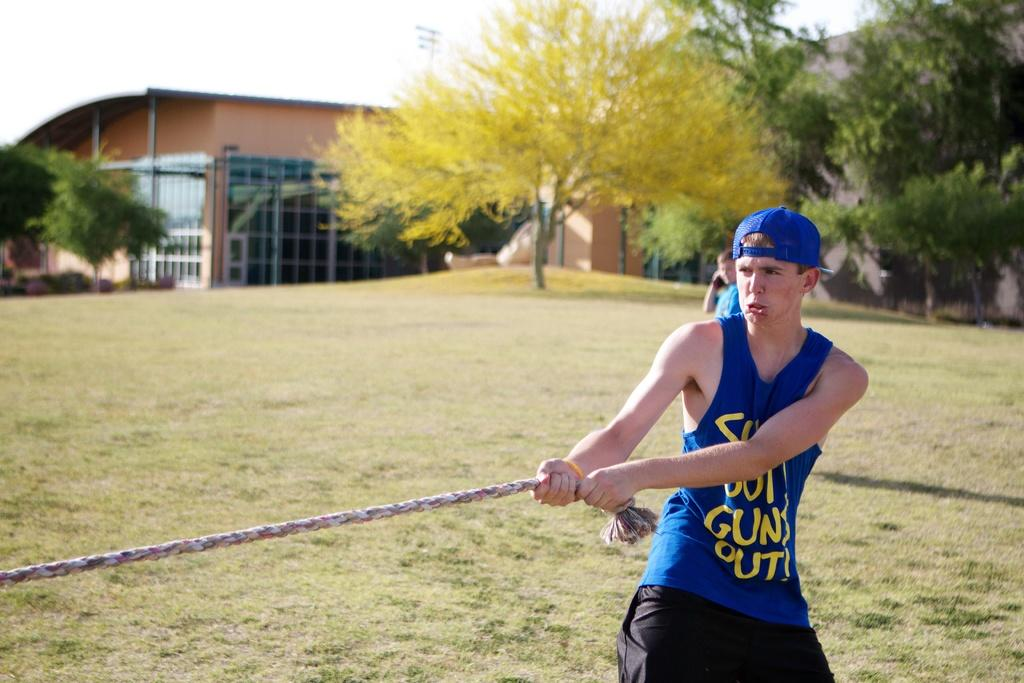<image>
Offer a succinct explanation of the picture presented. A boy pulling a rope that is wearing a shirt about a Gun Out. 